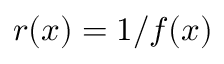Convert formula to latex. <formula><loc_0><loc_0><loc_500><loc_500>r ( x ) = 1 / f ( x )</formula> 